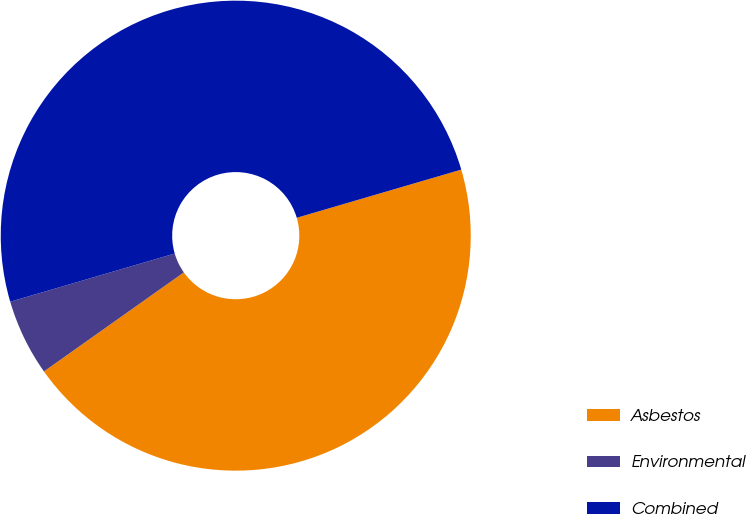Convert chart to OTSL. <chart><loc_0><loc_0><loc_500><loc_500><pie_chart><fcel>Asbestos<fcel>Environmental<fcel>Combined<nl><fcel>44.73%<fcel>5.27%<fcel>50.0%<nl></chart> 